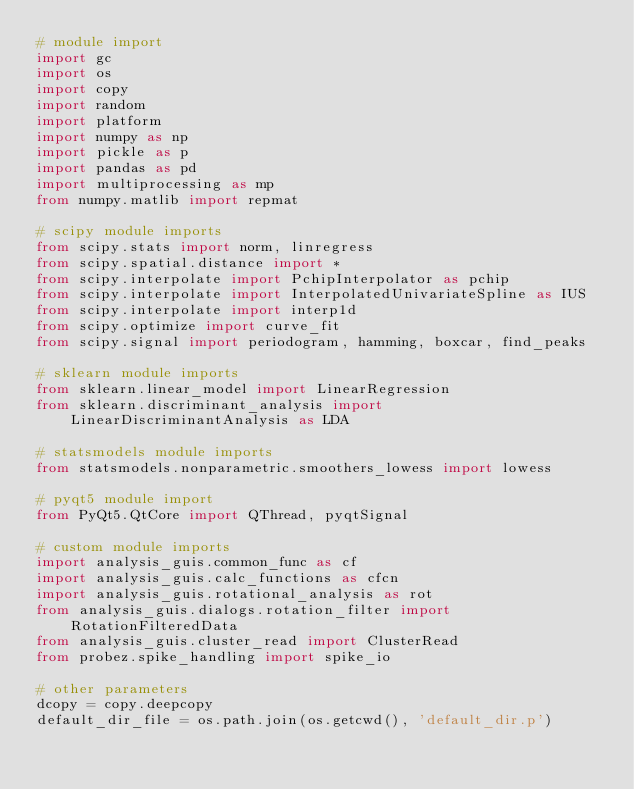Convert code to text. <code><loc_0><loc_0><loc_500><loc_500><_Python_># module import
import gc
import os
import copy
import random
import platform
import numpy as np
import pickle as p
import pandas as pd
import multiprocessing as mp
from numpy.matlib import repmat

# scipy module imports
from scipy.stats import norm, linregress
from scipy.spatial.distance import *
from scipy.interpolate import PchipInterpolator as pchip
from scipy.interpolate import InterpolatedUnivariateSpline as IUS
from scipy.interpolate import interp1d
from scipy.optimize import curve_fit
from scipy.signal import periodogram, hamming, boxcar, find_peaks

# sklearn module imports
from sklearn.linear_model import LinearRegression
from sklearn.discriminant_analysis import LinearDiscriminantAnalysis as LDA

# statsmodels module imports
from statsmodels.nonparametric.smoothers_lowess import lowess

# pyqt5 module import
from PyQt5.QtCore import QThread, pyqtSignal

# custom module imports
import analysis_guis.common_func as cf
import analysis_guis.calc_functions as cfcn
import analysis_guis.rotational_analysis as rot
from analysis_guis.dialogs.rotation_filter import RotationFilteredData
from analysis_guis.cluster_read import ClusterRead
from probez.spike_handling import spike_io

# other parameters
dcopy = copy.deepcopy
default_dir_file = os.path.join(os.getcwd(), 'default_dir.p')</code> 